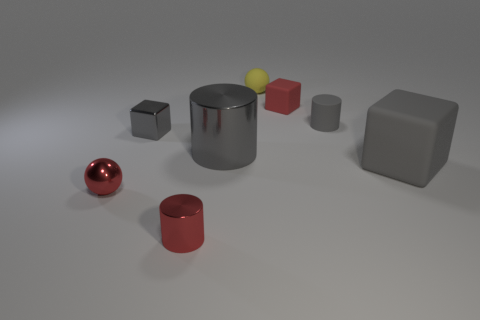What material is the red cylinder that is the same size as the red metal ball?
Give a very brief answer. Metal. How many tiny objects are red matte spheres or metal things?
Ensure brevity in your answer.  3. Is there a metal thing?
Make the answer very short. Yes. What size is the gray cylinder that is made of the same material as the large block?
Make the answer very short. Small. Does the large gray cylinder have the same material as the small red block?
Ensure brevity in your answer.  No. How many other objects are the same material as the small red cylinder?
Keep it short and to the point. 3. How many things are on the right side of the metallic ball and left of the yellow ball?
Ensure brevity in your answer.  3. What color is the big cube?
Offer a very short reply. Gray. There is another gray thing that is the same shape as the big gray metallic object; what is it made of?
Keep it short and to the point. Rubber. Do the large matte thing and the tiny metallic cube have the same color?
Provide a succinct answer. Yes. 